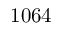<formula> <loc_0><loc_0><loc_500><loc_500>1 0 6 4</formula> 